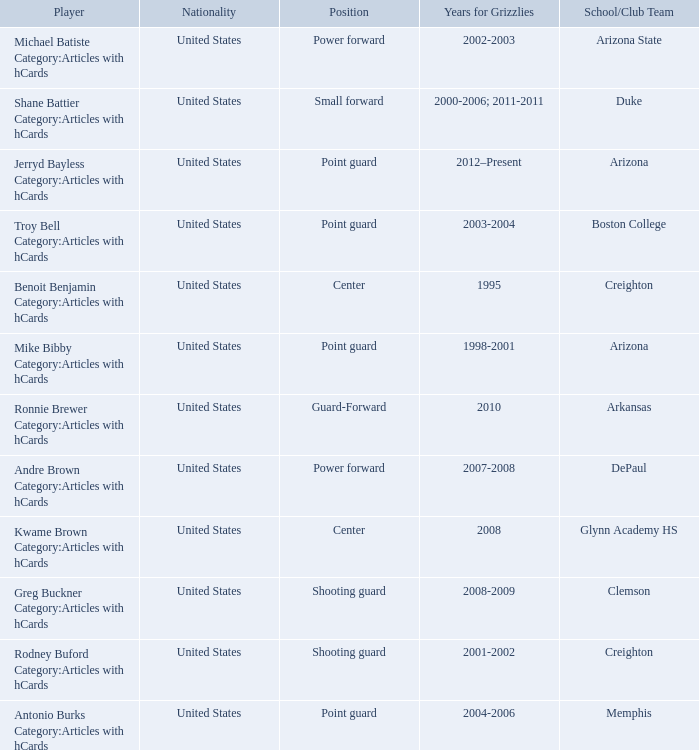Who was a member of the grizzlies roster during the 2002-2003 season? Michael Batiste Category:Articles with hCards. 